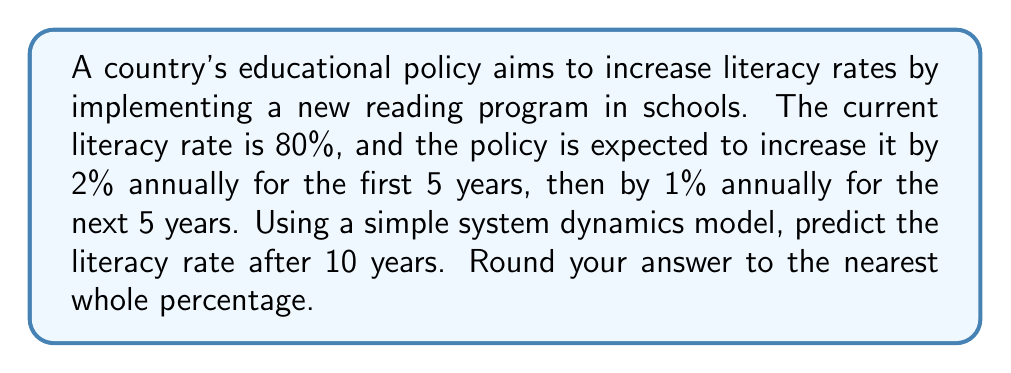Could you help me with this problem? Let's approach this step-by-step using a system dynamics model:

1) Initial literacy rate: $L_0 = 80\%$

2) For the first 5 years (t = 1 to 5):
   Annual increase: 2%
   $L_t = L_{t-1} + 0.02L_{t-1} = 1.02L_{t-1}$

3) For the next 5 years (t = 6 to 10):
   Annual increase: 1%
   $L_t = L_{t-1} + 0.01L_{t-1} = 1.01L_{t-1}$

4) Let's calculate year by year:

   Year 1: $L_1 = 1.02 \times 80\% = 81.60\%$
   Year 2: $L_2 = 1.02 \times 81.60\% = 83.23\%$
   Year 3: $L_3 = 1.02 \times 83.23\% = 84.90\%$
   Year 4: $L_4 = 1.02 \times 84.90\% = 86.59\%$
   Year 5: $L_5 = 1.02 \times 86.59\% = 88.33\%$

   Year 6: $L_6 = 1.01 \times 88.33\% = 89.21\%$
   Year 7: $L_7 = 1.01 \times 89.21\% = 90.10\%$
   Year 8: $L_8 = 1.01 \times 90.10\% = 91.00\%$
   Year 9: $L_9 = 1.01 \times 91.00\% = 91.91\%$
   Year 10: $L_{10} = 1.01 \times 91.91\% = 92.83\%$

5) Rounding to the nearest whole percentage: 93%
Answer: 93% 